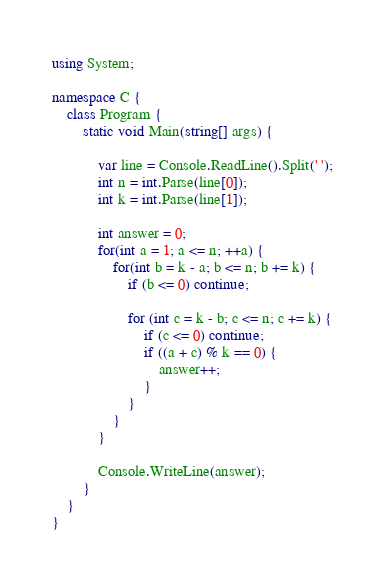<code> <loc_0><loc_0><loc_500><loc_500><_C#_>using System;

namespace C {
    class Program {
        static void Main(string[] args) {

            var line = Console.ReadLine().Split(' ');
            int n = int.Parse(line[0]);
            int k = int.Parse(line[1]);

            int answer = 0;
            for(int a = 1; a <= n; ++a) {
                for(int b = k - a; b <= n; b += k) {
                    if (b <= 0) continue;
                    
                    for (int c = k - b; c <= n; c += k) {
                        if (c <= 0) continue;
                        if ((a + c) % k == 0) {
                            answer++;
                        }
                    }
                }
            }

            Console.WriteLine(answer);
        }
    }
}
</code> 